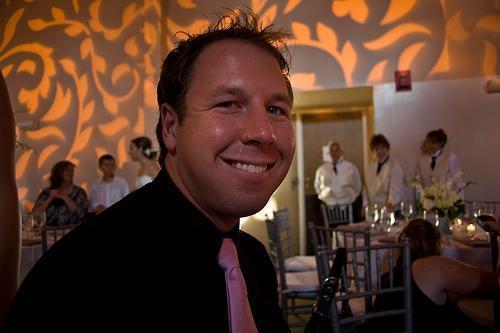How many members of the wait staff are there?
Give a very brief answer. 3. How many people have on black shirts?
Give a very brief answer. 1. 